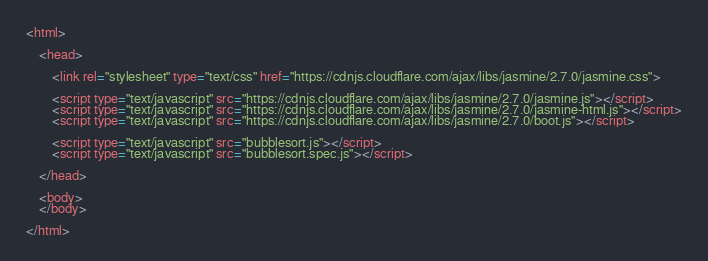Convert code to text. <code><loc_0><loc_0><loc_500><loc_500><_HTML_><html>

    <head>

        <link rel="stylesheet" type="text/css" href="https://cdnjs.cloudflare.com/ajax/libs/jasmine/2.7.0/jasmine.css">

        <script type="text/javascript" src="https://cdnjs.cloudflare.com/ajax/libs/jasmine/2.7.0/jasmine.js"></script>
        <script type="text/javascript" src="https://cdnjs.cloudflare.com/ajax/libs/jasmine/2.7.0/jasmine-html.js"></script>
        <script type="text/javascript" src="https://cdnjs.cloudflare.com/ajax/libs/jasmine/2.7.0/boot.js"></script>

        <script type="text/javascript" src="bubblesort.js"></script>
        <script type="text/javascript" src="bubblesort.spec.js"></script>

    </head>

    <body>
    </body>

</html>
</code> 